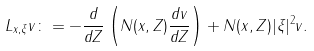Convert formula to latex. <formula><loc_0><loc_0><loc_500><loc_500>L _ { { { x } , \xi } } v \colon = - \frac { d } { d Z } \left ( N ( { x } , Z ) \frac { d v } { d Z } \right ) + N ( { x } , Z ) | \xi | ^ { 2 } v .</formula> 